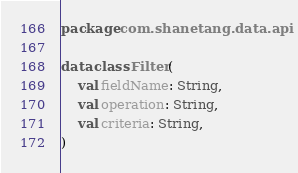Convert code to text. <code><loc_0><loc_0><loc_500><loc_500><_Kotlin_>package com.shanetang.data.api

data class Filter(
    val fieldName: String,
    val operation: String,
    val criteria: String,
)
</code> 